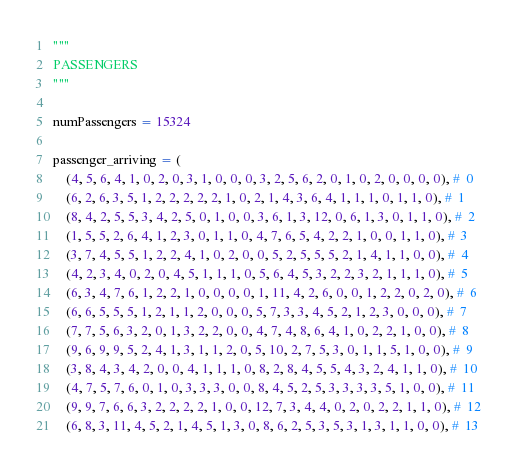Convert code to text. <code><loc_0><loc_0><loc_500><loc_500><_Python_>
"""
PASSENGERS
"""

numPassengers = 15324

passenger_arriving = (
	(4, 5, 6, 4, 1, 0, 2, 0, 3, 1, 0, 0, 0, 3, 2, 5, 6, 2, 0, 1, 0, 2, 0, 0, 0, 0), #  0
	(6, 2, 6, 3, 5, 1, 2, 2, 2, 2, 2, 1, 0, 2, 1, 4, 3, 6, 4, 1, 1, 1, 0, 1, 1, 0), #  1
	(8, 4, 2, 5, 5, 3, 4, 2, 5, 0, 1, 0, 0, 3, 6, 1, 3, 12, 0, 6, 1, 3, 0, 1, 1, 0), #  2
	(1, 5, 5, 2, 6, 4, 1, 2, 3, 0, 1, 1, 0, 4, 7, 6, 5, 4, 2, 2, 1, 0, 0, 1, 1, 0), #  3
	(3, 7, 4, 5, 5, 1, 2, 2, 4, 1, 0, 2, 0, 0, 5, 2, 5, 5, 5, 2, 1, 4, 1, 1, 0, 0), #  4
	(4, 2, 3, 4, 0, 2, 0, 4, 5, 1, 1, 1, 0, 5, 6, 4, 5, 3, 2, 2, 3, 2, 1, 1, 1, 0), #  5
	(6, 3, 4, 7, 6, 1, 2, 2, 1, 0, 0, 0, 0, 1, 11, 4, 2, 6, 0, 0, 1, 2, 2, 0, 2, 0), #  6
	(6, 6, 5, 5, 5, 1, 2, 1, 1, 2, 0, 0, 0, 5, 7, 3, 3, 4, 5, 2, 1, 2, 3, 0, 0, 0), #  7
	(7, 7, 5, 6, 3, 2, 0, 1, 3, 2, 2, 0, 0, 4, 7, 4, 8, 6, 4, 1, 0, 2, 2, 1, 0, 0), #  8
	(9, 6, 9, 9, 5, 2, 4, 1, 3, 1, 1, 2, 0, 5, 10, 2, 7, 5, 3, 0, 1, 1, 5, 1, 0, 0), #  9
	(3, 8, 4, 3, 4, 2, 0, 0, 4, 1, 1, 1, 0, 8, 2, 8, 4, 5, 5, 4, 3, 2, 4, 1, 1, 0), #  10
	(4, 7, 5, 7, 6, 0, 1, 0, 3, 3, 3, 0, 0, 8, 4, 5, 2, 5, 3, 3, 3, 3, 5, 1, 0, 0), #  11
	(9, 9, 7, 6, 6, 3, 2, 2, 2, 2, 1, 0, 0, 12, 7, 3, 4, 4, 0, 2, 0, 2, 2, 1, 1, 0), #  12
	(6, 8, 3, 11, 4, 5, 2, 1, 4, 5, 1, 3, 0, 8, 6, 2, 5, 3, 5, 3, 1, 3, 1, 1, 0, 0), #  13</code> 